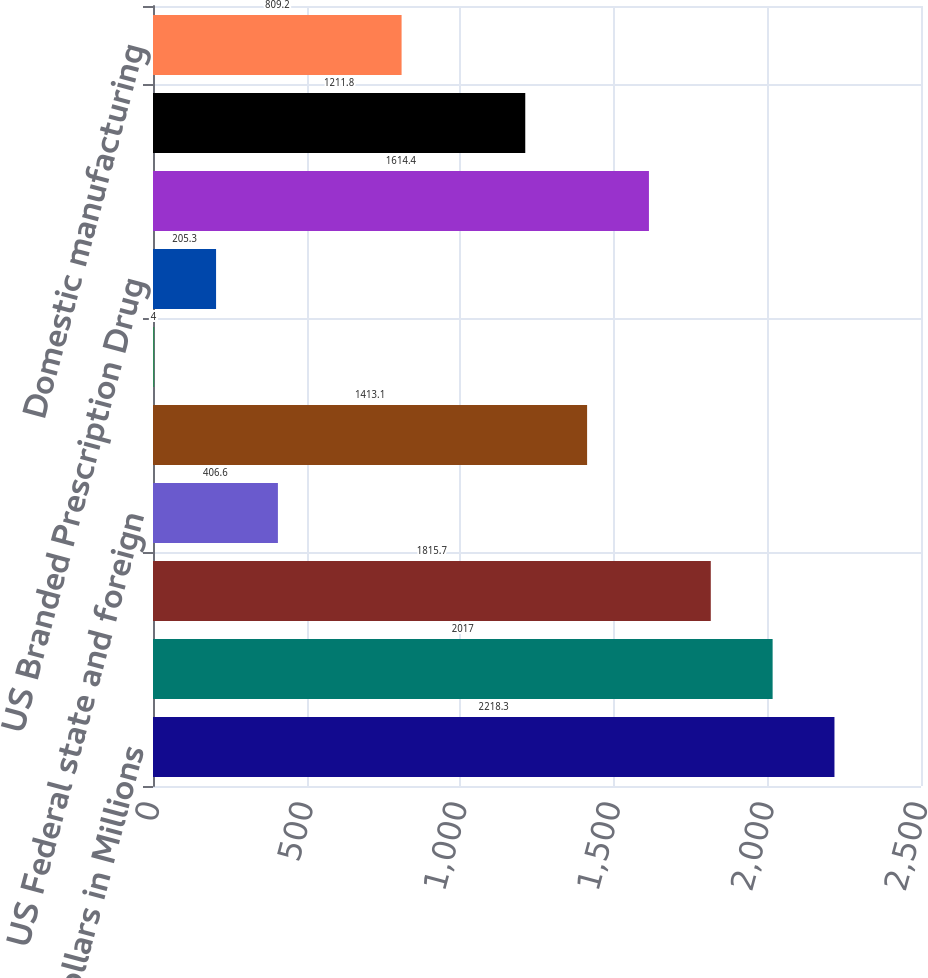<chart> <loc_0><loc_0><loc_500><loc_500><bar_chart><fcel>Dollars in Millions<fcel>US statutory rate<fcel>Foreign tax effect of certain<fcel>US Federal state and foreign<fcel>US Federal research based<fcel>Goodwill allocated to<fcel>US Branded Prescription Drug<fcel>Non-deductible R&D charges<fcel>Puerto Rico excise tax<fcel>Domestic manufacturing<nl><fcel>2218.3<fcel>2017<fcel>1815.7<fcel>406.6<fcel>1413.1<fcel>4<fcel>205.3<fcel>1614.4<fcel>1211.8<fcel>809.2<nl></chart> 